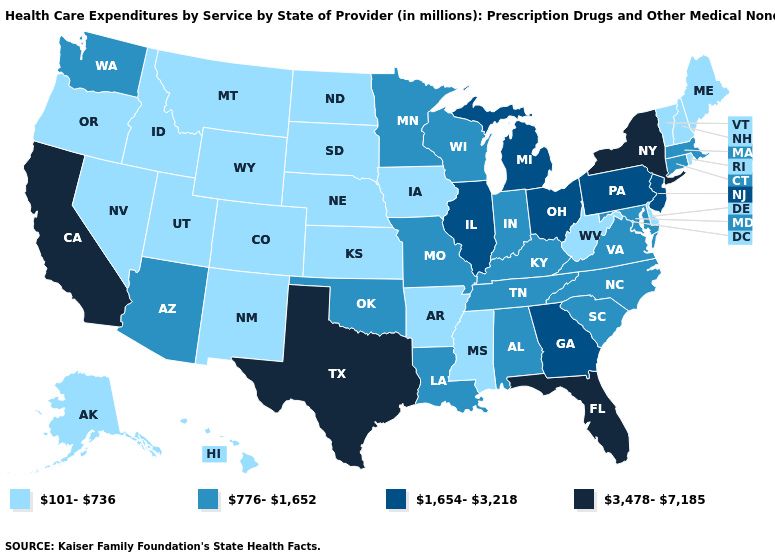Does New York have a higher value than Texas?
Concise answer only. No. Name the states that have a value in the range 101-736?
Quick response, please. Alaska, Arkansas, Colorado, Delaware, Hawaii, Idaho, Iowa, Kansas, Maine, Mississippi, Montana, Nebraska, Nevada, New Hampshire, New Mexico, North Dakota, Oregon, Rhode Island, South Dakota, Utah, Vermont, West Virginia, Wyoming. Does Florida have the highest value in the USA?
Short answer required. Yes. What is the value of New Mexico?
Quick response, please. 101-736. Does Iowa have the highest value in the MidWest?
Keep it brief. No. Does the map have missing data?
Concise answer only. No. Which states have the lowest value in the USA?
Short answer required. Alaska, Arkansas, Colorado, Delaware, Hawaii, Idaho, Iowa, Kansas, Maine, Mississippi, Montana, Nebraska, Nevada, New Hampshire, New Mexico, North Dakota, Oregon, Rhode Island, South Dakota, Utah, Vermont, West Virginia, Wyoming. Does Virginia have the lowest value in the South?
Give a very brief answer. No. Name the states that have a value in the range 1,654-3,218?
Write a very short answer. Georgia, Illinois, Michigan, New Jersey, Ohio, Pennsylvania. Does Vermont have the lowest value in the Northeast?
Write a very short answer. Yes. What is the value of Alaska?
Short answer required. 101-736. What is the value of Illinois?
Answer briefly. 1,654-3,218. What is the value of Illinois?
Concise answer only. 1,654-3,218. What is the value of Florida?
Quick response, please. 3,478-7,185. Does Arkansas have the same value as Mississippi?
Be succinct. Yes. 